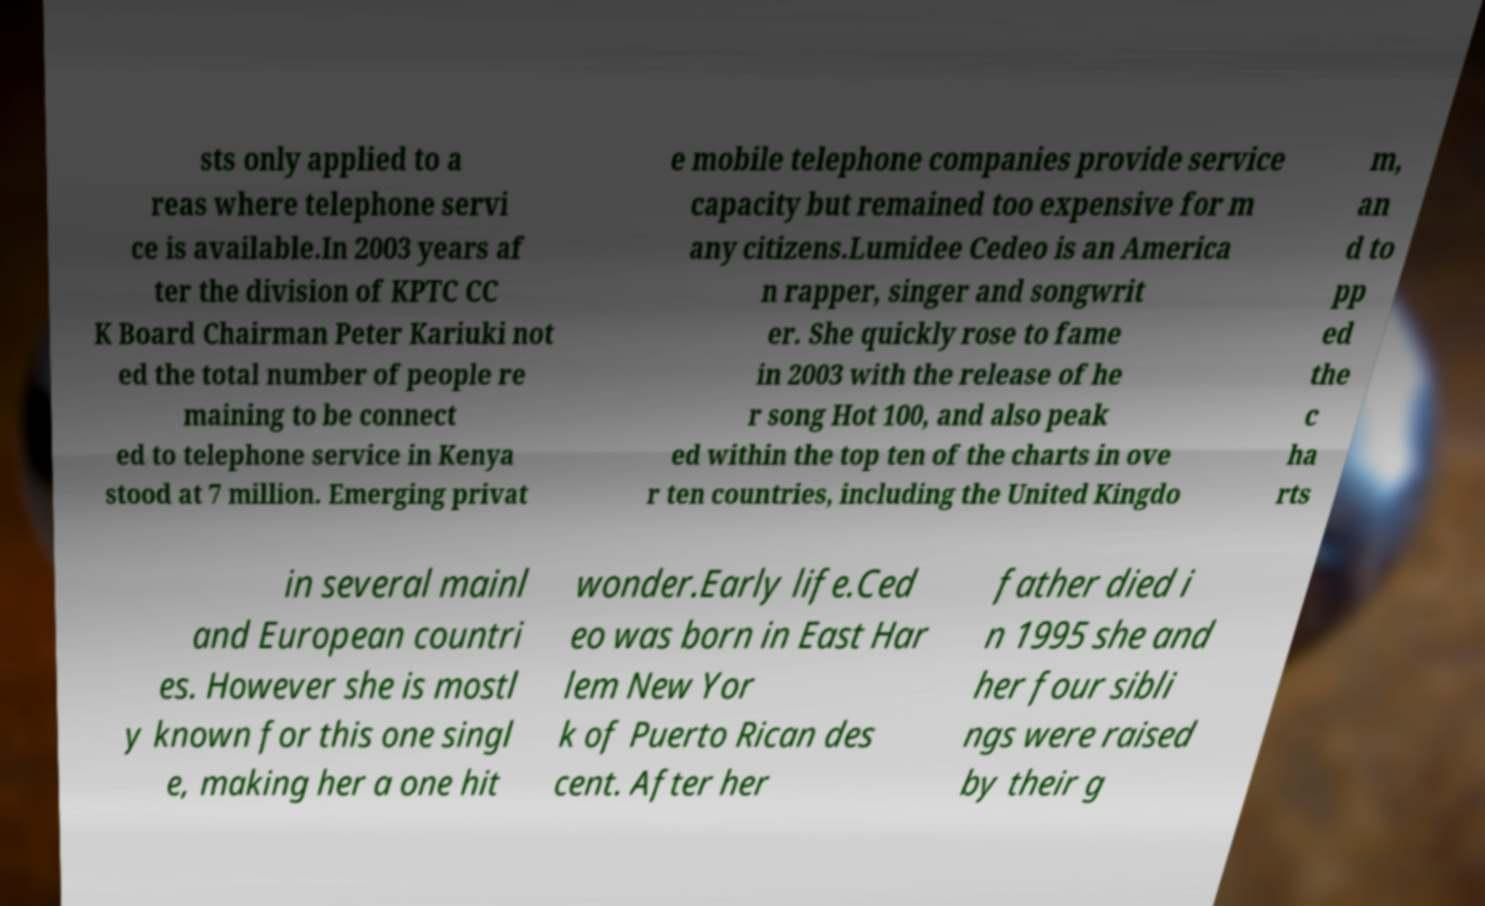I need the written content from this picture converted into text. Can you do that? sts only applied to a reas where telephone servi ce is available.In 2003 years af ter the division of KPTC CC K Board Chairman Peter Kariuki not ed the total number of people re maining to be connect ed to telephone service in Kenya stood at 7 million. Emerging privat e mobile telephone companies provide service capacity but remained too expensive for m any citizens.Lumidee Cedeo is an America n rapper, singer and songwrit er. She quickly rose to fame in 2003 with the release of he r song Hot 100, and also peak ed within the top ten of the charts in ove r ten countries, including the United Kingdo m, an d to pp ed the c ha rts in several mainl and European countri es. However she is mostl y known for this one singl e, making her a one hit wonder.Early life.Ced eo was born in East Har lem New Yor k of Puerto Rican des cent. After her father died i n 1995 she and her four sibli ngs were raised by their g 